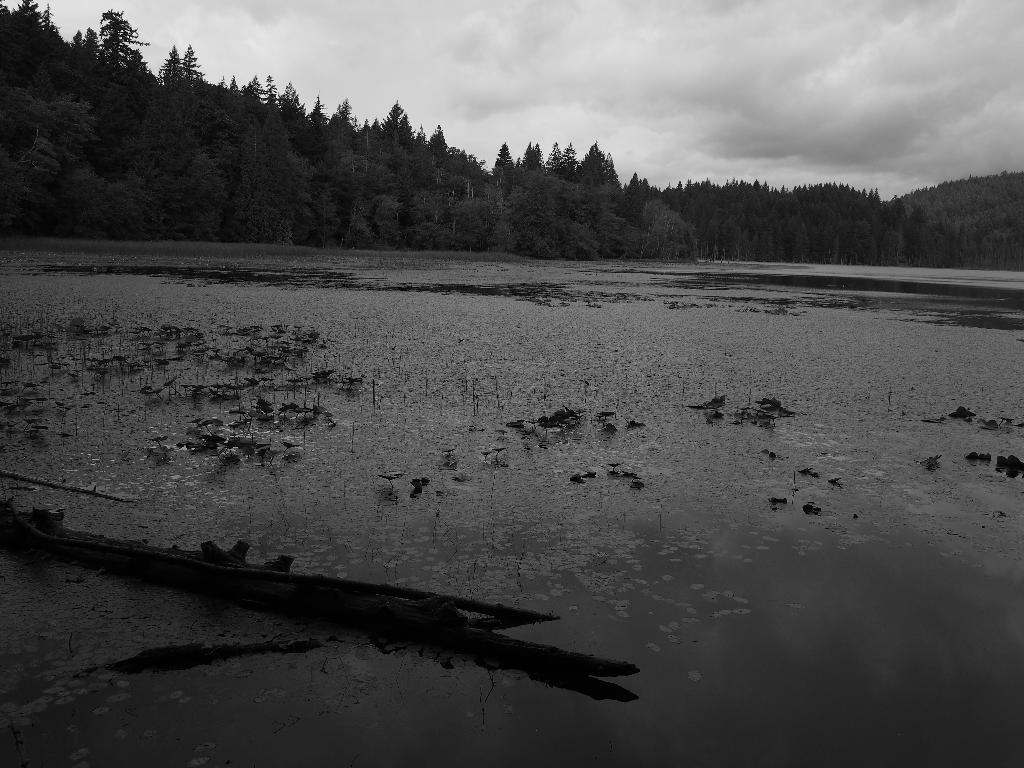What is on the surface in the image? There is water on the surface in the image. What can be seen in the background of the image? There are trees in the background of the image. What is visible in the sky in the image? Clouds are visible in the sky in the image. What type of punishment is being given to the trees in the image? There is no punishment being given to the trees in the image; they are simply visible in the background. 